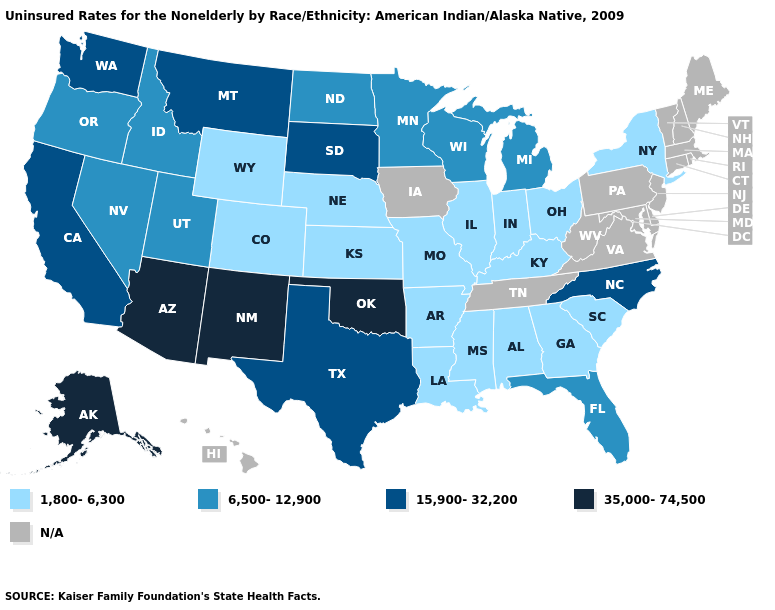Does New Mexico have the highest value in the USA?
Write a very short answer. Yes. Among the states that border South Dakota , which have the lowest value?
Be succinct. Nebraska, Wyoming. Among the states that border Michigan , does Wisconsin have the highest value?
Answer briefly. Yes. What is the highest value in states that border West Virginia?
Keep it brief. 1,800-6,300. What is the highest value in the USA?
Concise answer only. 35,000-74,500. Among the states that border Arizona , does Colorado have the lowest value?
Be succinct. Yes. What is the value of Delaware?
Quick response, please. N/A. Name the states that have a value in the range 15,900-32,200?
Be succinct. California, Montana, North Carolina, South Dakota, Texas, Washington. Which states have the highest value in the USA?
Be succinct. Alaska, Arizona, New Mexico, Oklahoma. What is the value of West Virginia?
Concise answer only. N/A. Name the states that have a value in the range 15,900-32,200?
Keep it brief. California, Montana, North Carolina, South Dakota, Texas, Washington. What is the lowest value in states that border Arizona?
Short answer required. 1,800-6,300. 